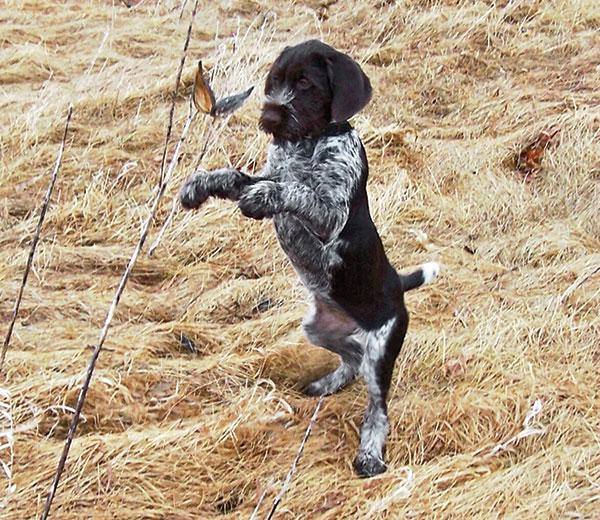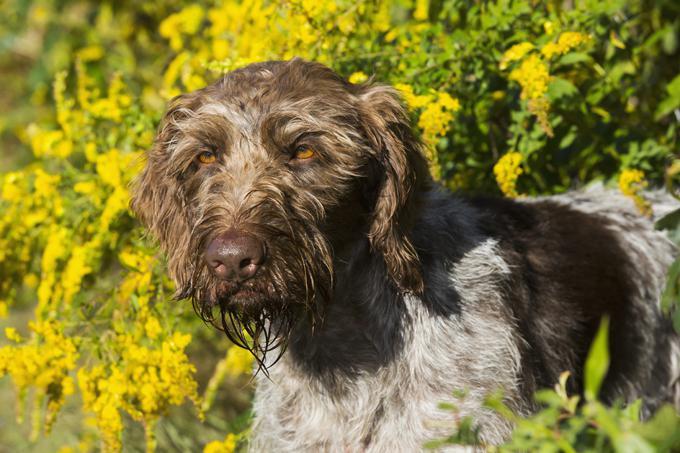The first image is the image on the left, the second image is the image on the right. Assess this claim about the two images: "The right image features a dog on something elevated, and the left image includes a dog and at least one dead game bird.". Correct or not? Answer yes or no. No. The first image is the image on the left, the second image is the image on the right. Analyze the images presented: Is the assertion "A dog is sitting in the right image." valid? Answer yes or no. No. 